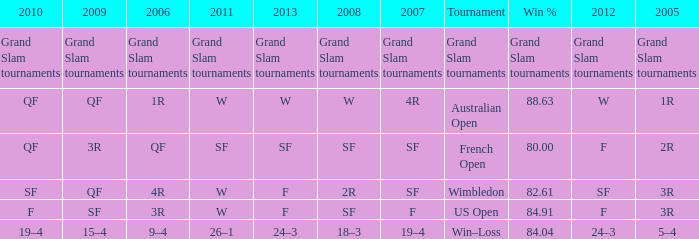WHat in 2005 has a Win % of 82.61? 3R. 